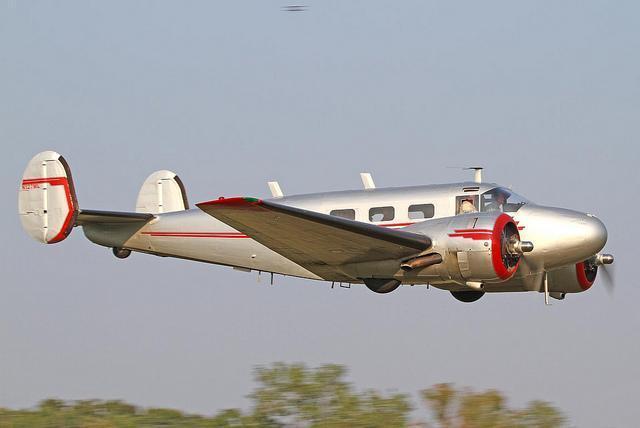How many engines does the plane have?
Give a very brief answer. 2. 